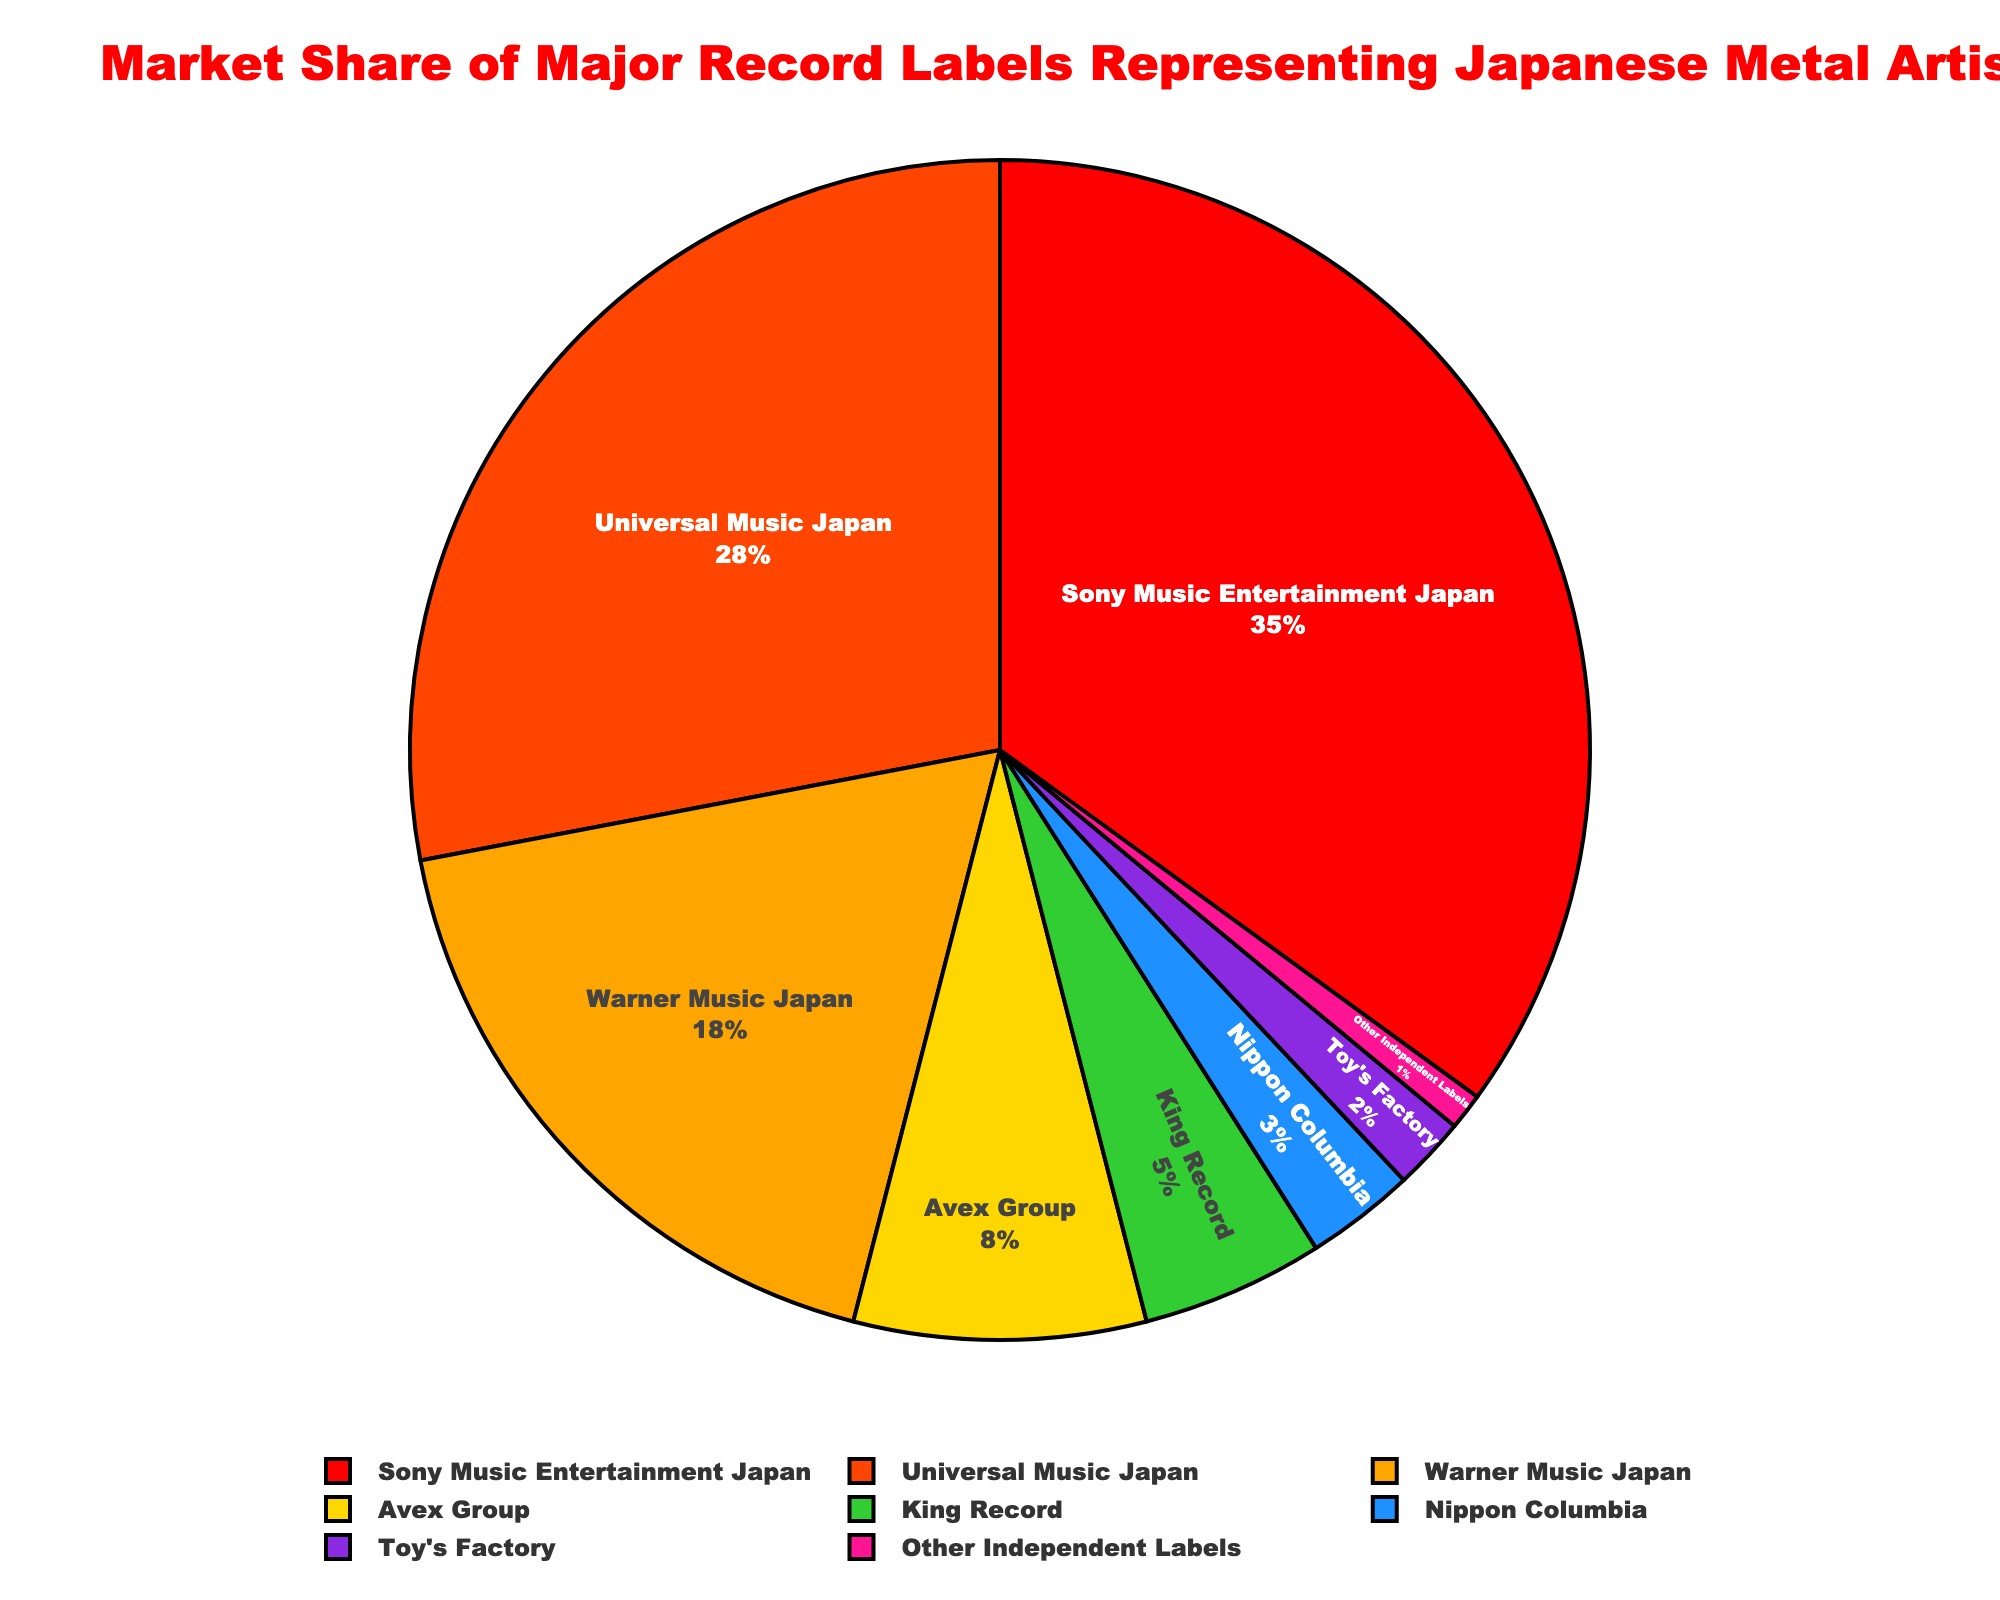What's the combined market share of Sony Music Entertainment Japan and Universal Music Japan? Add the market shares of Sony Music Entertainment Japan (35) and Universal Music Japan (28). So, 35 + 28 = 63
Answer: 63 Which record label has the smallest market share, and what is it? Identify the label with the smallest percentage, which is Toy's Factory with a market share of 2.
Answer: Toy's Factory, 2 How much greater is the market share of Warner Music Japan compared to Avex Group? Subtract Avex Group's market share (8) from Warner Music Japan's (18). So, 18 - 8 = 10
Answer: 10 What is the difference in market share between the label with the largest share and the label with the smallest share? Subtract the smallest market share (1 from Other Independent Labels) from the largest market share (35 from Sony Music Entertainment Japan). So, 35 - 1 = 34
Answer: 34 What is the average market share of the labels with less than 10% market share? Identify the labels (Avex Group, King Record, Nippon Columbia, Toy's Factory, Other Independent Labels), sum their shares (8 + 5 + 3 + 2 + 1 = 19), and divide by the number of labels (5). So, 19 / 5 = 3.8
Answer: 3.8 How many labels have a market share greater than 20%? Identify the labels with market shares greater than 20%: Sony Music Entertainment Japan (35) and Universal Music Japan (28). Count these labels (2).
Answer: 2 Which label has the second-largest market share and what is it? Identify the label with the second-largest market share, which is Universal Music Japan with a market share of 28.
Answer: Universal Music Japan, 28 What percentage of the market is held by labels with a market share of 5% or more? Sum the market shares of the labels with 5% or more: Sony Music Entertainment Japan (35) + Universal Music Japan (28) + Warner Music Japan (18) + Avex Group (8) + King Record (5) = 94
Answer: 94 How do the combined market shares of King Record and Nippon Columbia compare to the market share of Warner Music Japan? Add the market shares of King Record (5) and Nippon Columbia (3), then compare to Warner Music Japan's share (18). 5 + 3 = 8, which is less than 18.
Answer: Less than Warner Music Japan What is the most prominent visual feature used to distinguish Sony Music Entertainment Japan in the chart? Sony Music Entertainment Japan is distinguished by having a significantly larger slice and a specific color (red) in the pie chart.
Answer: Larger slice, red color 